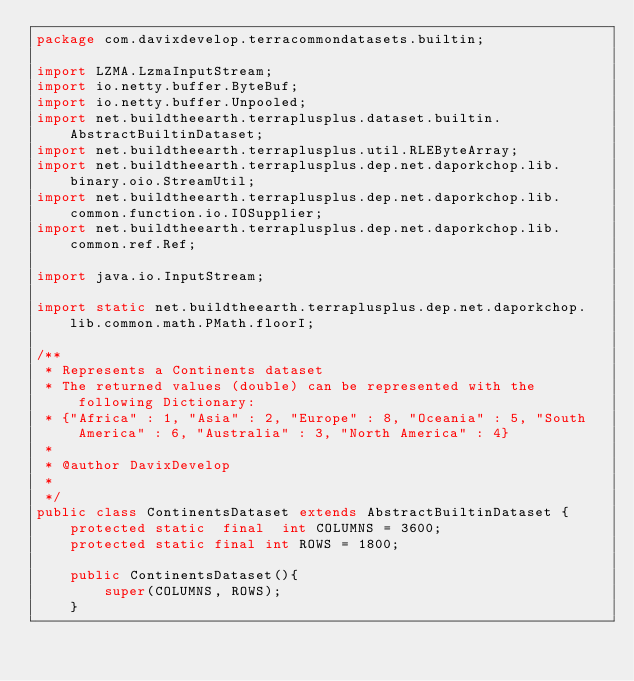Convert code to text. <code><loc_0><loc_0><loc_500><loc_500><_Java_>package com.davixdevelop.terracommondatasets.builtin;

import LZMA.LzmaInputStream;
import io.netty.buffer.ByteBuf;
import io.netty.buffer.Unpooled;
import net.buildtheearth.terraplusplus.dataset.builtin.AbstractBuiltinDataset;
import net.buildtheearth.terraplusplus.util.RLEByteArray;
import net.buildtheearth.terraplusplus.dep.net.daporkchop.lib.binary.oio.StreamUtil;
import net.buildtheearth.terraplusplus.dep.net.daporkchop.lib.common.function.io.IOSupplier;
import net.buildtheearth.terraplusplus.dep.net.daporkchop.lib.common.ref.Ref;

import java.io.InputStream;

import static net.buildtheearth.terraplusplus.dep.net.daporkchop.lib.common.math.PMath.floorI;

/**
 * Represents a Continents dataset
 * The returned values (double) can be represented with the following Dictionary:
 * {"Africa" : 1, "Asia" : 2, "Europe" : 8, "Oceania" : 5, "South America" : 6, "Australia" : 3, "North America" : 4}
 *
 * @author DavixDevelop
 *
 */
public class ContinentsDataset extends AbstractBuiltinDataset {
    protected static  final  int COLUMNS = 3600;
    protected static final int ROWS = 1800;

    public ContinentsDataset(){
        super(COLUMNS, ROWS);
    }
</code> 